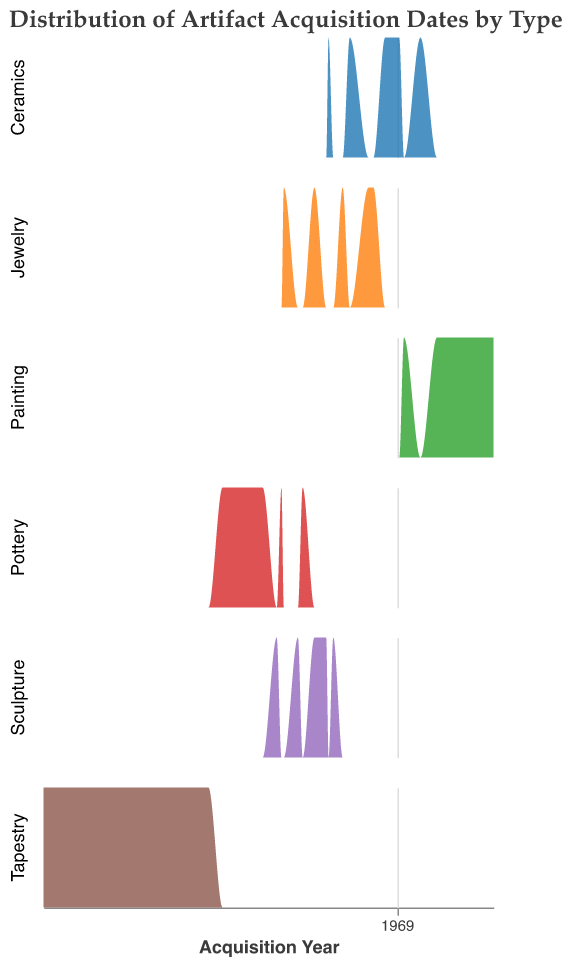What is the title of the plot? The title is displayed at the top of the chart and typically summarizes the main information being presented. Here, it informs us about the distribution of artifact acquisition dates broken down by artifact type.
Answer: Distribution of Artifact Acquisition Dates by Type What are the axis labels in the plot? The x-axis label represents the time dimension as "Acquisition Year", indicating when the artifacts were acquired. The y-axis does not have a label but represents the count of acquisitions for each year.
Answer: Acquisition Year Which artifact type appears to have the earliest acquisition date? By looking at the peaks of the density plots for each artifact type, we can identify which type shows the earliest acquisition year. The "Tapestry" type has the earliest peak around the year 1800.
Answer: Tapestry Which artifact type shows the highest peak in the density plot? The highest peak represents the highest count of acquisitions for any year. The "Painting" type shows the highest peak around the mid-20th century, indicating there was a significant number of paintings acquired during that time.
Answer: Painting Are there any artifact types that have a continuous acquisition span from the early 19th century to late 20th century? By examining the range of the density plots for each artifact type, we can determine if acquisitions were recorded over a long period. "Pottery" and "Ceramics" have continuous spans from the early 19th century to the late 20th century.
Answer: Pottery, Ceramics How do the acquisition dates of sculpture compare to those of tapestry? By comparing the timing and spread of density plots, we observe that sculptures were mostly acquired between the late 19th century to early 20th century, while tapestries show acquisitions starting earlier, from around 1800 to the mid-19th century.
Answer: Sculptures were mostly later Which artifact types show a peak around 1915? Observing the density plots, we can see which types have a noticeable peak around the year 1915. The types "Jewelry" and "Sculpture" both have peaks around this year.
Answer: Jewelry, Sculpture Which period saw the highest acquisition of ceramics? By examining the peak of the density plot for ceramics, we can identify the period with the highest count. The highest acquisitions occurred around the year 1950.
Answer: Around 1950 From the plot, which types of artifacts were acquired in the 1980s? The density plots that extend into the 1980s will indicate the types of artifacts acquired during this period. "Painting" shows acquisitions extending into the 1980s.
Answer: Painting Are there any artifact types whose acquisitions peaked before 1850? By observing the density plots, we can determine which types have peaks before the year 1850. "Tapestry" shows a peak starting from around 1800 to 1850.
Answer: Tapestry 